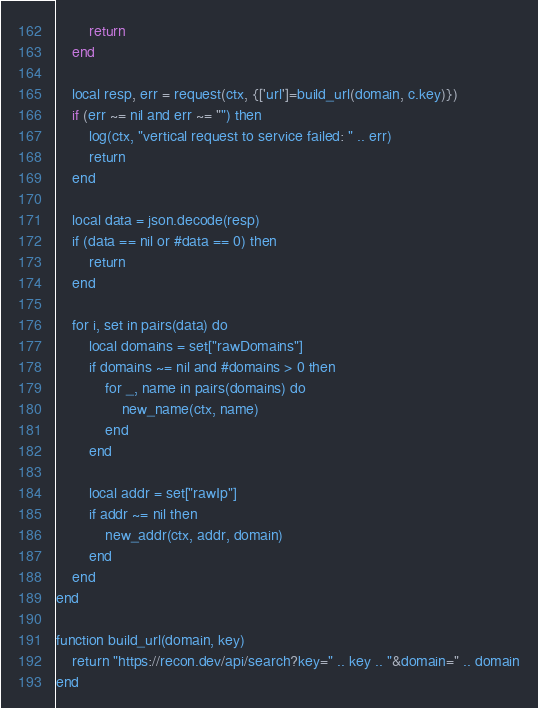<code> <loc_0><loc_0><loc_500><loc_500><_Ada_>        return
    end

    local resp, err = request(ctx, {['url']=build_url(domain, c.key)})
    if (err ~= nil and err ~= "") then
        log(ctx, "vertical request to service failed: " .. err)
        return
    end

    local data = json.decode(resp)
    if (data == nil or #data == 0) then
        return
    end

    for i, set in pairs(data) do
        local domains = set["rawDomains"]
        if domains ~= nil and #domains > 0 then
            for _, name in pairs(domains) do
                new_name(ctx, name)
            end
        end

        local addr = set["rawIp"]
        if addr ~= nil then
            new_addr(ctx, addr, domain)
        end
    end
end

function build_url(domain, key)
    return "https://recon.dev/api/search?key=" .. key .. "&domain=" .. domain
end
</code> 